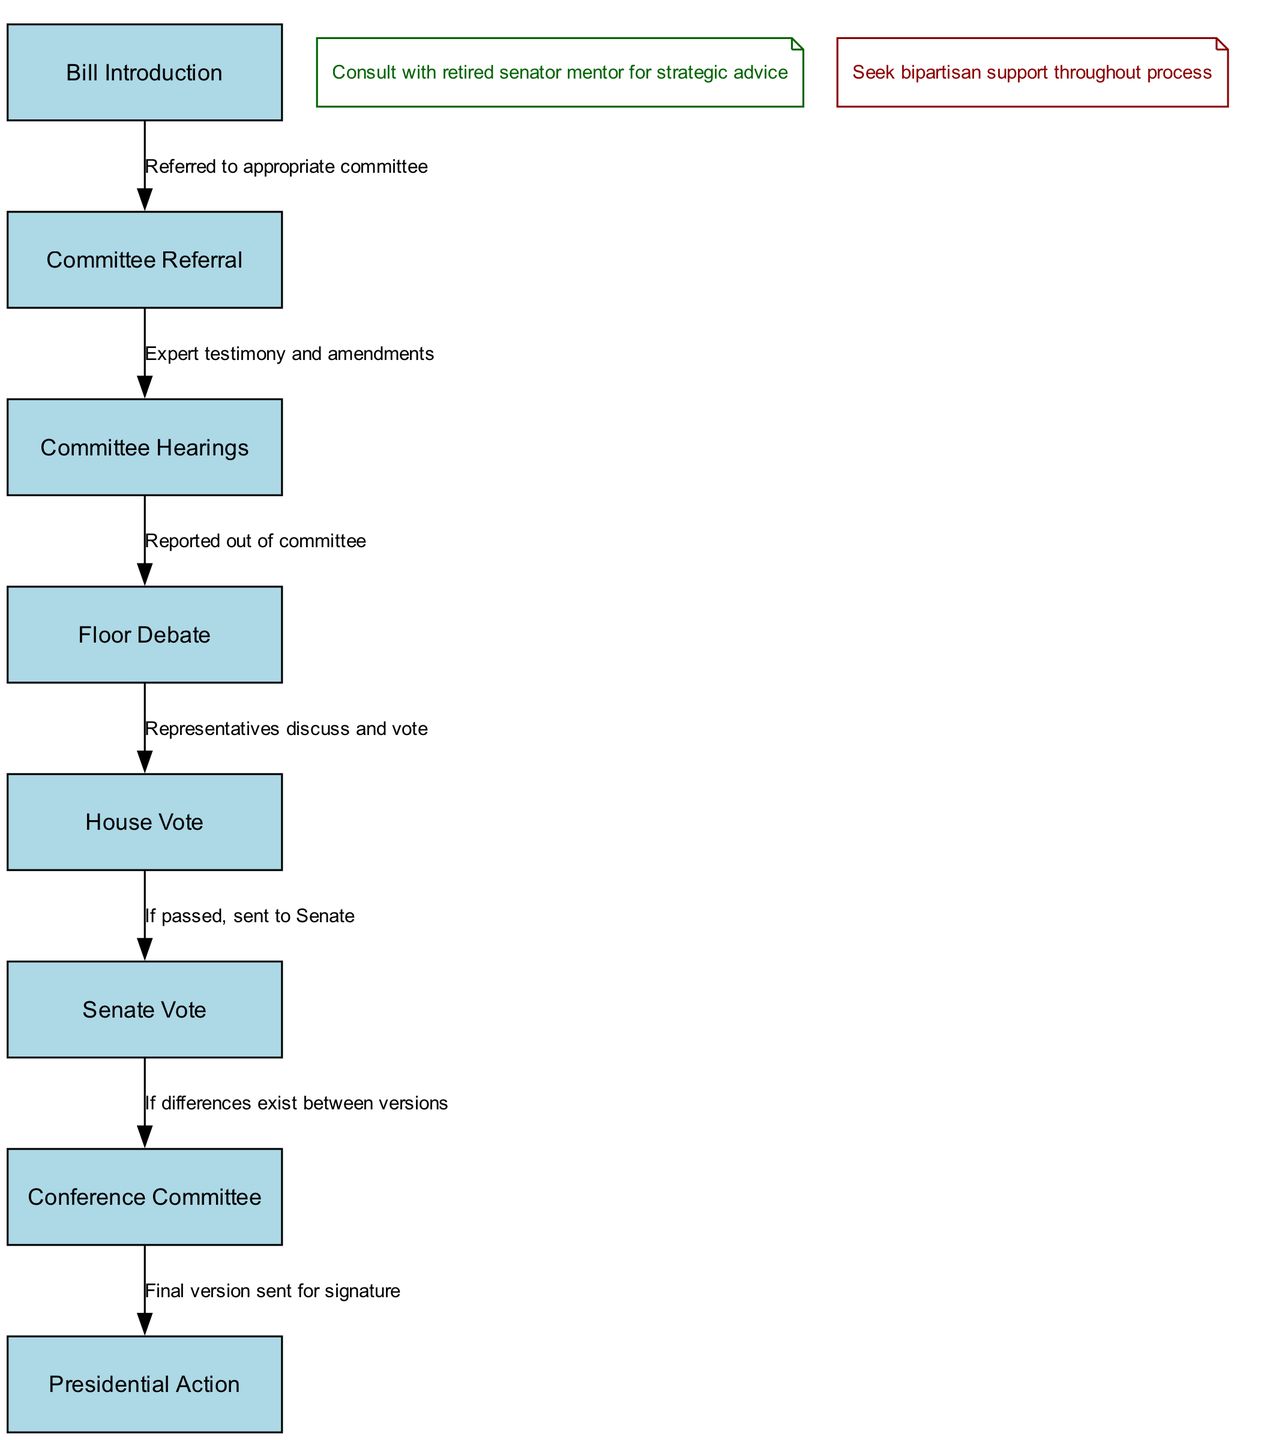What is the first step in the legislative process? The diagram clearly indicates that "Bill Introduction" is the first node in the process, representing the initial action taken when beginning legislation.
Answer: Bill Introduction How many nodes are in the diagram? By counting the listed nodes in the diagram, we see there are 8 distinct stages represented, from Bill Introduction to Presidential Action.
Answer: 8 What follows Committee Hearings? The diagram shows that after "Committee Hearings," the next step is "Floor Debate," indicating the progression of the legislative process.
Answer: Floor Debate What happens if the House Vote passes? According to the diagram, if the House Vote is successful, the next action is that the bill is "sent to Senate," reflecting the legislative flow.
Answer: Sent to Senate In which situation is a Conference Committee involved? The diagram points out that a Conference Committee comes into play if there are "differences exist between versions," emphasizing its role in reconciling variations.
Answer: Differences exist between versions What is the final step in the legislative process? The last node in the flowchart is "Presidential Action," which signifies that after all preceding steps, the bill awaits the President's signature.
Answer: Presidential Action What type of support should be sought throughout the process? The diagram includes a note suggesting that "bipartisan support" is essential throughout the legislative process, indicating a strategic focus on collaboration.
Answer: Bipartisan support What is reported out of committee? The diagram illustrates that after Committee Hearings, what is reported out is the outcome of the discussions, specifically referred to as "Reported out of committee."
Answer: Reported out of committee 